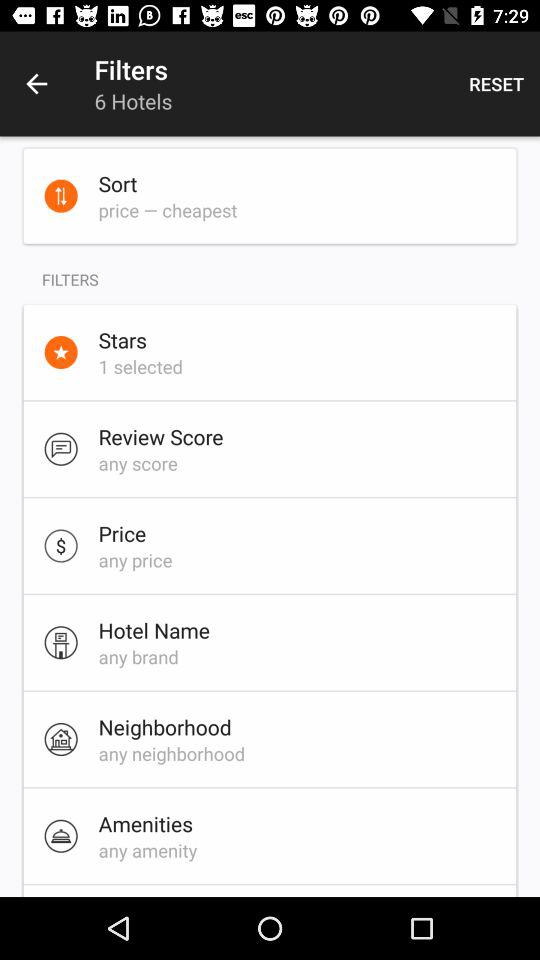How many filters are there in total?
Answer the question using a single word or phrase. 6 